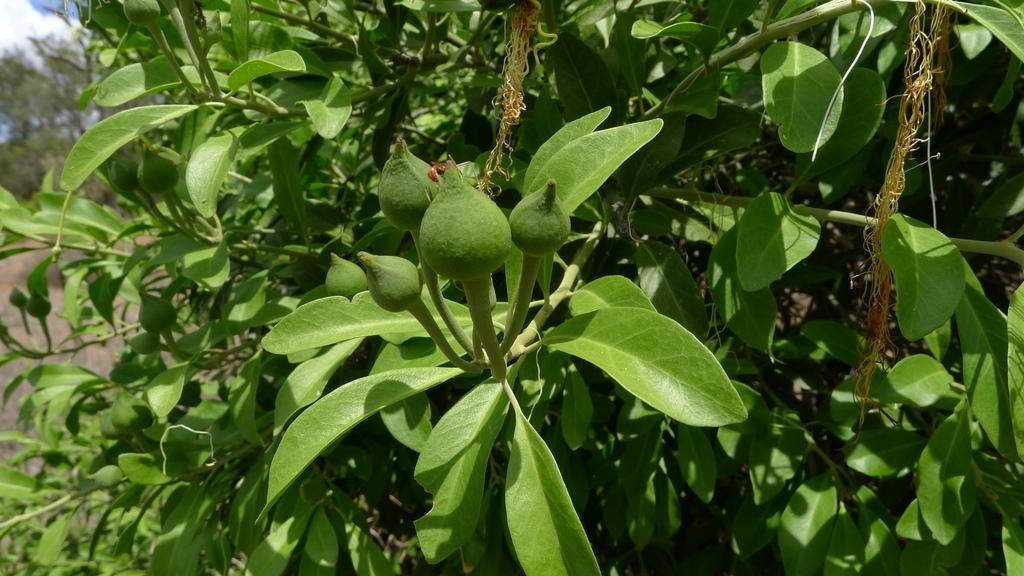What is the main subject in the center of the image? There is a tree in the center of the image. What can be seen on the tree? There are fruits on the tree, and they are green in color. What is visible in the background of the image? The sky and clouds are visible in the background of the image. Are there any other trees in the image? Yes, there are trees in the background of the image. What type of pollution can be seen in the image? There is no pollution visible in the image; it features a tree with green fruits and a background of sky, clouds, and trees. What kind of bread is being used to make the picture? There is no bread present in the image; it is a photograph of a tree with fruits and a background of sky, clouds, and trees. 